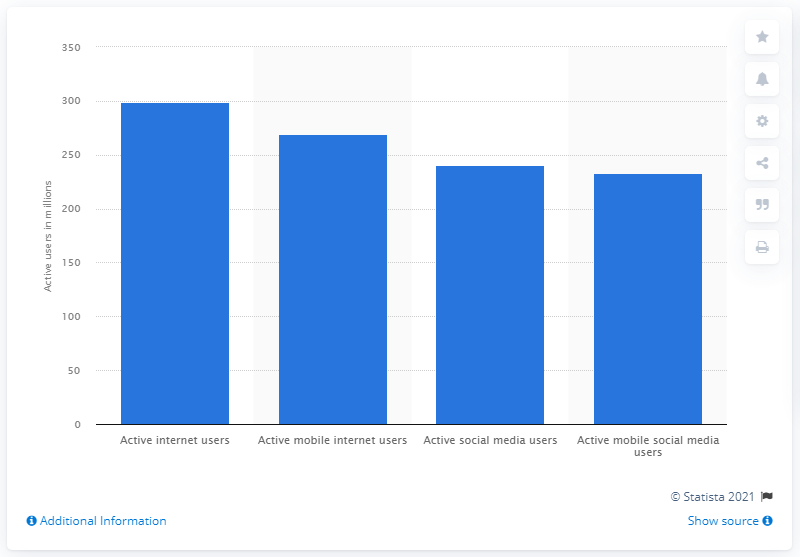Mention a couple of crucial points in this snapshot. 233.3 people accessed their accounts via mobile. As of January 2021, there were 269.5 mobile internet users in the United States. 